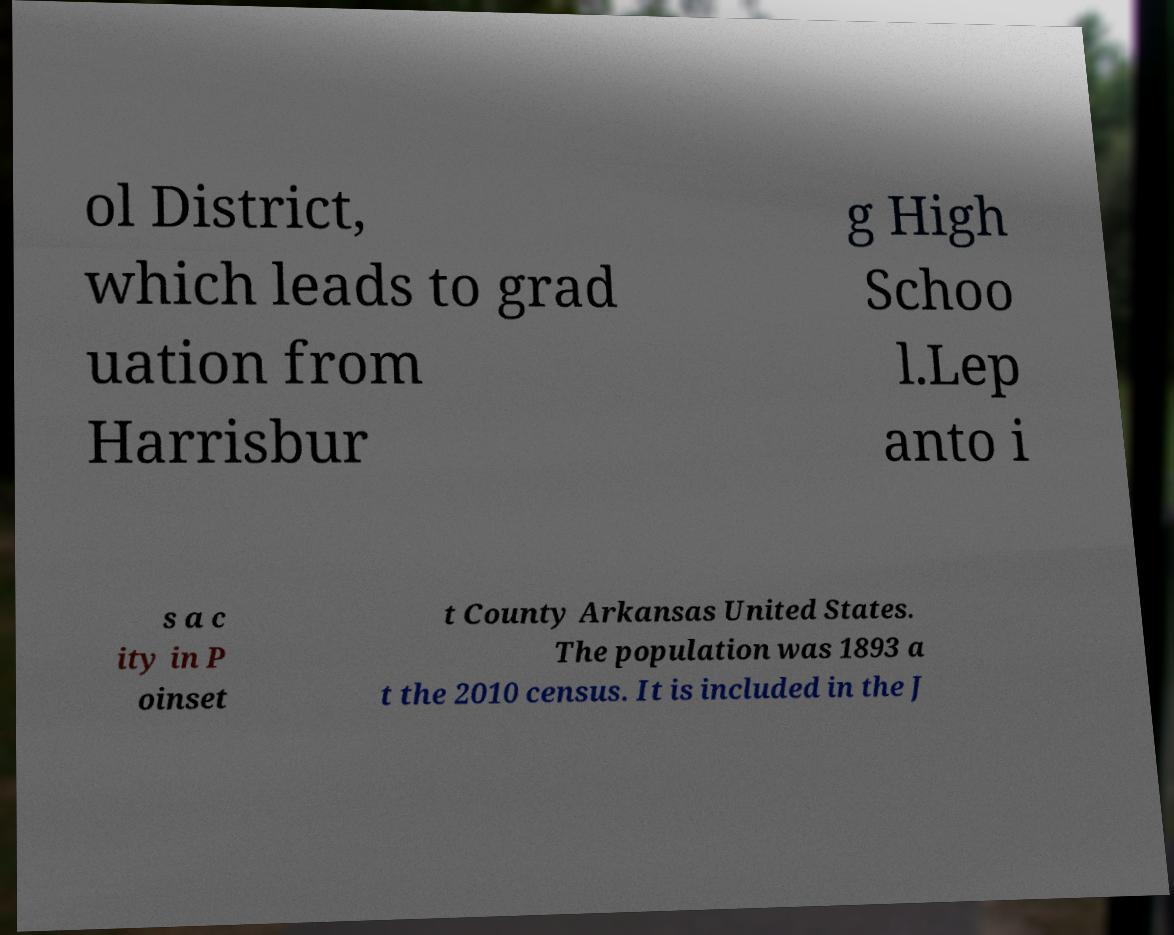There's text embedded in this image that I need extracted. Can you transcribe it verbatim? ol District, which leads to grad uation from Harrisbur g High Schoo l.Lep anto i s a c ity in P oinset t County Arkansas United States. The population was 1893 a t the 2010 census. It is included in the J 